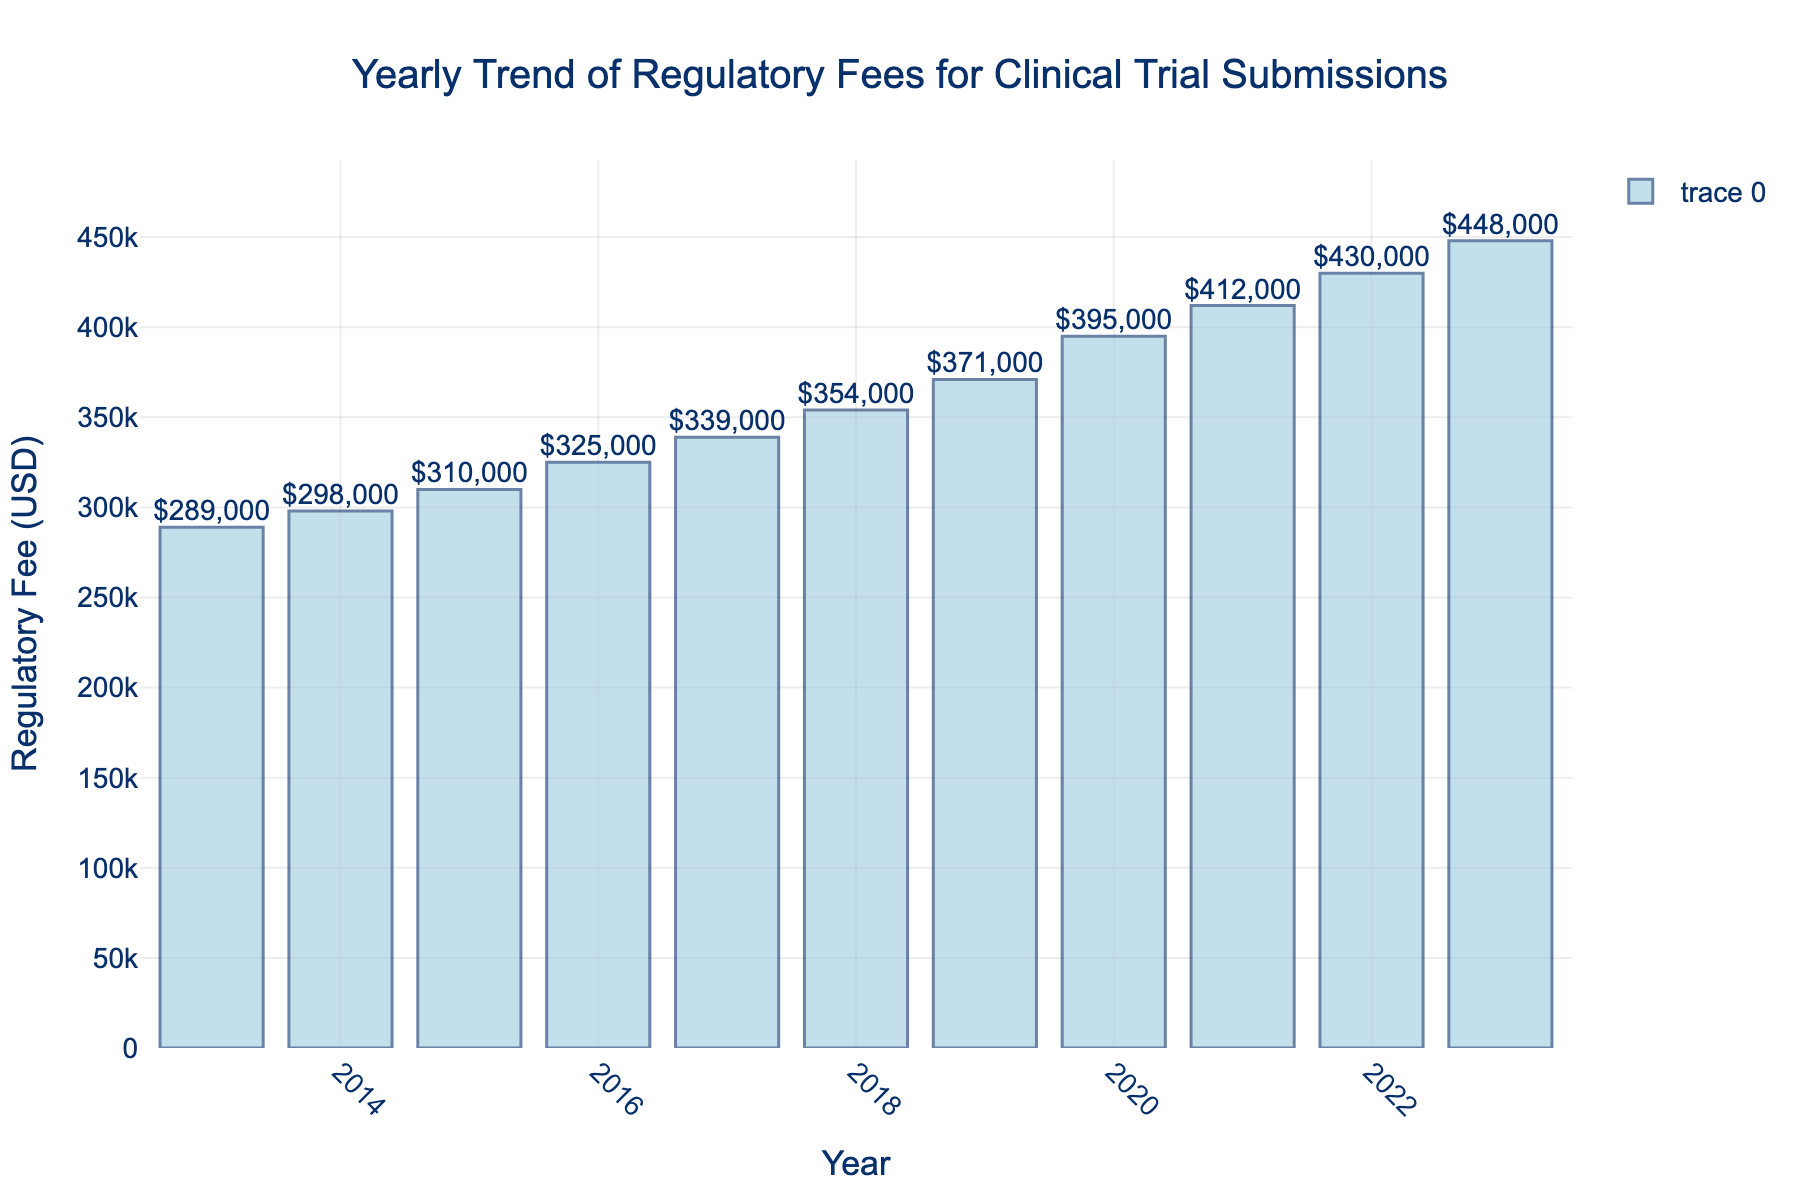What's the average regulatory fee from 2017 to 2020? First, locate the years 2017 to 2020 on the x-axis. The corresponding regulatory fees for these years are $339,000 (2017), $354,000 (2018), $371,000 (2019), and $395,000 (2020). Sum them: $339,000 + $354,000 + $371,000 + $395,000 = $1,459,000. Divide by the number of years (4) to get the average: $1,459,000 / 4 = $364,750
Answer: $364,750 Which year had the highest regulatory fee? Look at the height of the bars. The bar for 2023 is the tallest, indicating the highest regulatory fee
Answer: 2023 What is the difference in regulatory fees between 2015 and 2020? Identify the regulatory fees for the years 2015 and 2020, which are $310,000 and $395,000 respectively. Subtract the 2015 fee from the 2020 fee: $395,000 - $310,000 = $85,000
Answer: $85,000 By how much did the regulatory fee change from 2019 to 2023? The regulatory fee in 2019 was $371,000 and in 2023 it was $448,000. Subtract the 2019 fee from the 2023 fee: $448,000 - $371,000 = $77,000
Answer: $77,000 Is there any year where the regulatory fee decreased compared to the previous year? Visually inspect the bars to see if any bar is shorter than its predecessor. All bars increase in height as years progress, indicating no decrease
Answer: No What's the total sum of regulatory fees from 2013 to 2016? Locate the fees for 2013, 2014, 2015, and 2016 which are $289,000, $298,000, $310,000, and $325,000 respectively. Sum them up: $289,000 + $298,000 + $310,000 + $325,000 = $1,222,000
Answer: $1,222,000 How much did the regulatory fee increase from 2013 to 2023? The fee in 2013 was $289,000 and in 2023 it was $448,000. Subtract the 2013 fee from the 2023 fee: $448,000 - $289,000 = $159,000
Answer: $159,000 